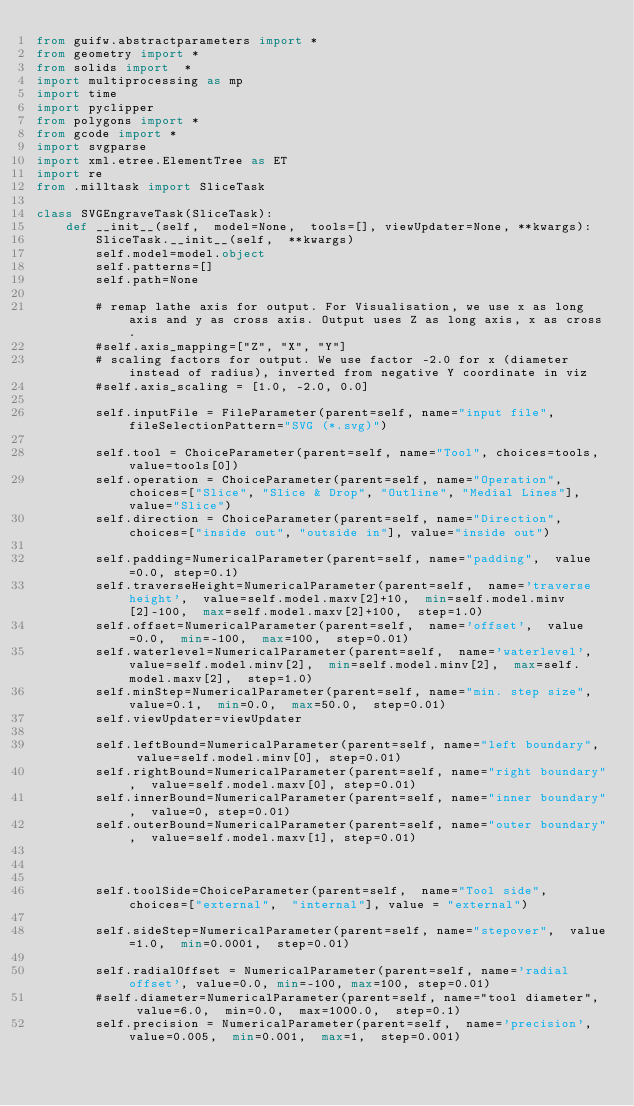<code> <loc_0><loc_0><loc_500><loc_500><_Python_>from guifw.abstractparameters import *
from geometry import *
from solids import  *
import multiprocessing as mp
import time
import pyclipper
from polygons import *
from gcode import *
import svgparse
import xml.etree.ElementTree as ET
import re
from .milltask import SliceTask

class SVGEngraveTask(SliceTask):
    def __init__(self,  model=None,  tools=[], viewUpdater=None, **kwargs):
        SliceTask.__init__(self,  **kwargs)
        self.model=model.object
        self.patterns=[]
        self.path=None

        # remap lathe axis for output. For Visualisation, we use x as long axis and y as cross axis. Output uses Z as long axis, x as cross.
        #self.axis_mapping=["Z", "X", "Y"]
        # scaling factors for output. We use factor -2.0 for x (diameter instead of radius), inverted from negative Y coordinate in viz
        #self.axis_scaling = [1.0, -2.0, 0.0]

        self.inputFile = FileParameter(parent=self, name="input file", fileSelectionPattern="SVG (*.svg)")

        self.tool = ChoiceParameter(parent=self, name="Tool", choices=tools, value=tools[0])
        self.operation = ChoiceParameter(parent=self, name="Operation", choices=["Slice", "Slice & Drop", "Outline", "Medial Lines"], value="Slice")
        self.direction = ChoiceParameter(parent=self, name="Direction", choices=["inside out", "outside in"], value="inside out")

        self.padding=NumericalParameter(parent=self, name="padding",  value=0.0, step=0.1)
        self.traverseHeight=NumericalParameter(parent=self,  name='traverse height',  value=self.model.maxv[2]+10,  min=self.model.minv[2]-100,  max=self.model.maxv[2]+100,  step=1.0)
        self.offset=NumericalParameter(parent=self,  name='offset',  value=0.0,  min=-100,  max=100,  step=0.01)
        self.waterlevel=NumericalParameter(parent=self,  name='waterlevel',  value=self.model.minv[2],  min=self.model.minv[2],  max=self.model.maxv[2],  step=1.0)
        self.minStep=NumericalParameter(parent=self, name="min. step size",  value=0.1,  min=0.0,  max=50.0,  step=0.01)
        self.viewUpdater=viewUpdater

        self.leftBound=NumericalParameter(parent=self, name="left boundary",  value=self.model.minv[0], step=0.01)
        self.rightBound=NumericalParameter(parent=self, name="right boundary",  value=self.model.maxv[0], step=0.01)
        self.innerBound=NumericalParameter(parent=self, name="inner boundary",  value=0, step=0.01)
        self.outerBound=NumericalParameter(parent=self, name="outer boundary",  value=self.model.maxv[1], step=0.01)



        self.toolSide=ChoiceParameter(parent=self,  name="Tool side",  choices=["external",  "internal"], value = "external")

        self.sideStep=NumericalParameter(parent=self, name="stepover",  value=1.0,  min=0.0001,  step=0.01)

        self.radialOffset = NumericalParameter(parent=self, name='radial offset', value=0.0, min=-100, max=100, step=0.01)
        #self.diameter=NumericalParameter(parent=self, name="tool diameter",  value=6.0,  min=0.0,  max=1000.0,  step=0.1)
        self.precision = NumericalParameter(parent=self,  name='precision',  value=0.005,  min=0.001,  max=1,  step=0.001)
</code> 